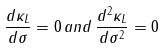<formula> <loc_0><loc_0><loc_500><loc_500>\frac { d \kappa _ { L } } { d \sigma } = 0 \, a n d \, \frac { d ^ { 2 } \kappa _ { L } } { d \sigma ^ { 2 } } = 0</formula> 